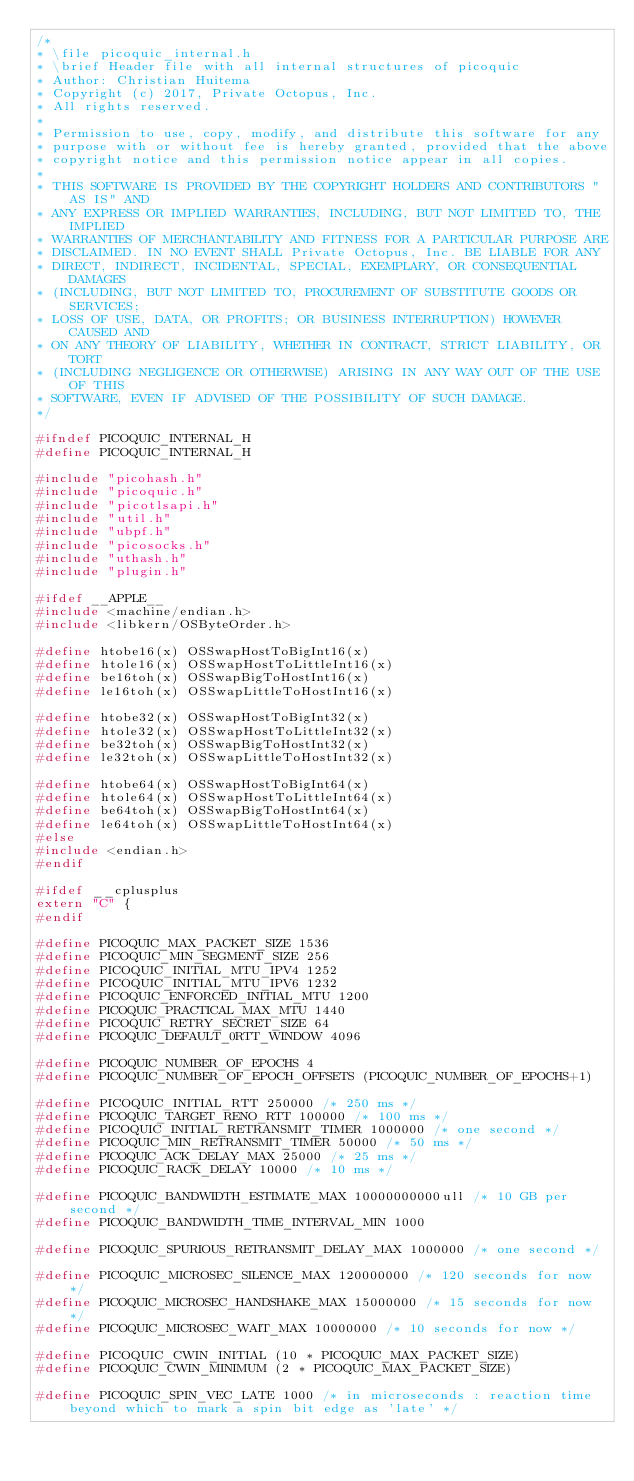<code> <loc_0><loc_0><loc_500><loc_500><_C_>/*
* \file picoquic_internal.h
* \brief Header file with all internal structures of picoquic
* Author: Christian Huitema
* Copyright (c) 2017, Private Octopus, Inc.
* All rights reserved.
*
* Permission to use, copy, modify, and distribute this software for any
* purpose with or without fee is hereby granted, provided that the above
* copyright notice and this permission notice appear in all copies.
*
* THIS SOFTWARE IS PROVIDED BY THE COPYRIGHT HOLDERS AND CONTRIBUTORS "AS IS" AND
* ANY EXPRESS OR IMPLIED WARRANTIES, INCLUDING, BUT NOT LIMITED TO, THE IMPLIED
* WARRANTIES OF MERCHANTABILITY AND FITNESS FOR A PARTICULAR PURPOSE ARE
* DISCLAIMED. IN NO EVENT SHALL Private Octopus, Inc. BE LIABLE FOR ANY
* DIRECT, INDIRECT, INCIDENTAL, SPECIAL, EXEMPLARY, OR CONSEQUENTIAL DAMAGES
* (INCLUDING, BUT NOT LIMITED TO, PROCUREMENT OF SUBSTITUTE GOODS OR SERVICES;
* LOSS OF USE, DATA, OR PROFITS; OR BUSINESS INTERRUPTION) HOWEVER CAUSED AND
* ON ANY THEORY OF LIABILITY, WHETHER IN CONTRACT, STRICT LIABILITY, OR TORT
* (INCLUDING NEGLIGENCE OR OTHERWISE) ARISING IN ANY WAY OUT OF THE USE OF THIS
* SOFTWARE, EVEN IF ADVISED OF THE POSSIBILITY OF SUCH DAMAGE.
*/

#ifndef PICOQUIC_INTERNAL_H
#define PICOQUIC_INTERNAL_H

#include "picohash.h"
#include "picoquic.h"
#include "picotlsapi.h"
#include "util.h"
#include "ubpf.h"
#include "picosocks.h"
#include "uthash.h"
#include "plugin.h"

#ifdef __APPLE__
#include <machine/endian.h>
#include <libkern/OSByteOrder.h>

#define htobe16(x) OSSwapHostToBigInt16(x)
#define htole16(x) OSSwapHostToLittleInt16(x)
#define be16toh(x) OSSwapBigToHostInt16(x)
#define le16toh(x) OSSwapLittleToHostInt16(x)

#define htobe32(x) OSSwapHostToBigInt32(x)
#define htole32(x) OSSwapHostToLittleInt32(x)
#define be32toh(x) OSSwapBigToHostInt32(x)
#define le32toh(x) OSSwapLittleToHostInt32(x)

#define htobe64(x) OSSwapHostToBigInt64(x)
#define htole64(x) OSSwapHostToLittleInt64(x)
#define be64toh(x) OSSwapBigToHostInt64(x)
#define le64toh(x) OSSwapLittleToHostInt64(x)
#else
#include <endian.h>
#endif

#ifdef __cplusplus
extern "C" {
#endif

#define PICOQUIC_MAX_PACKET_SIZE 1536
#define PICOQUIC_MIN_SEGMENT_SIZE 256
#define PICOQUIC_INITIAL_MTU_IPV4 1252
#define PICOQUIC_INITIAL_MTU_IPV6 1232
#define PICOQUIC_ENFORCED_INITIAL_MTU 1200
#define PICOQUIC_PRACTICAL_MAX_MTU 1440
#define PICOQUIC_RETRY_SECRET_SIZE 64
#define PICOQUIC_DEFAULT_0RTT_WINDOW 4096

#define PICOQUIC_NUMBER_OF_EPOCHS 4
#define PICOQUIC_NUMBER_OF_EPOCH_OFFSETS (PICOQUIC_NUMBER_OF_EPOCHS+1)

#define PICOQUIC_INITIAL_RTT 250000 /* 250 ms */
#define PICOQUIC_TARGET_RENO_RTT 100000 /* 100 ms */
#define PICOQUIC_INITIAL_RETRANSMIT_TIMER 1000000 /* one second */
#define PICOQUIC_MIN_RETRANSMIT_TIMER 50000 /* 50 ms */
#define PICOQUIC_ACK_DELAY_MAX 25000 /* 25 ms */
#define PICOQUIC_RACK_DELAY 10000 /* 10 ms */

#define PICOQUIC_BANDWIDTH_ESTIMATE_MAX 10000000000ull /* 10 GB per second */
#define PICOQUIC_BANDWIDTH_TIME_INTERVAL_MIN 1000

#define PICOQUIC_SPURIOUS_RETRANSMIT_DELAY_MAX 1000000 /* one second */

#define PICOQUIC_MICROSEC_SILENCE_MAX 120000000 /* 120 seconds for now */
#define PICOQUIC_MICROSEC_HANDSHAKE_MAX 15000000 /* 15 seconds for now */
#define PICOQUIC_MICROSEC_WAIT_MAX 10000000 /* 10 seconds for now */

#define PICOQUIC_CWIN_INITIAL (10 * PICOQUIC_MAX_PACKET_SIZE)
#define PICOQUIC_CWIN_MINIMUM (2 * PICOQUIC_MAX_PACKET_SIZE)

#define PICOQUIC_SPIN_VEC_LATE 1000 /* in microseconds : reaction time beyond which to mark a spin bit edge as 'late' */
</code> 